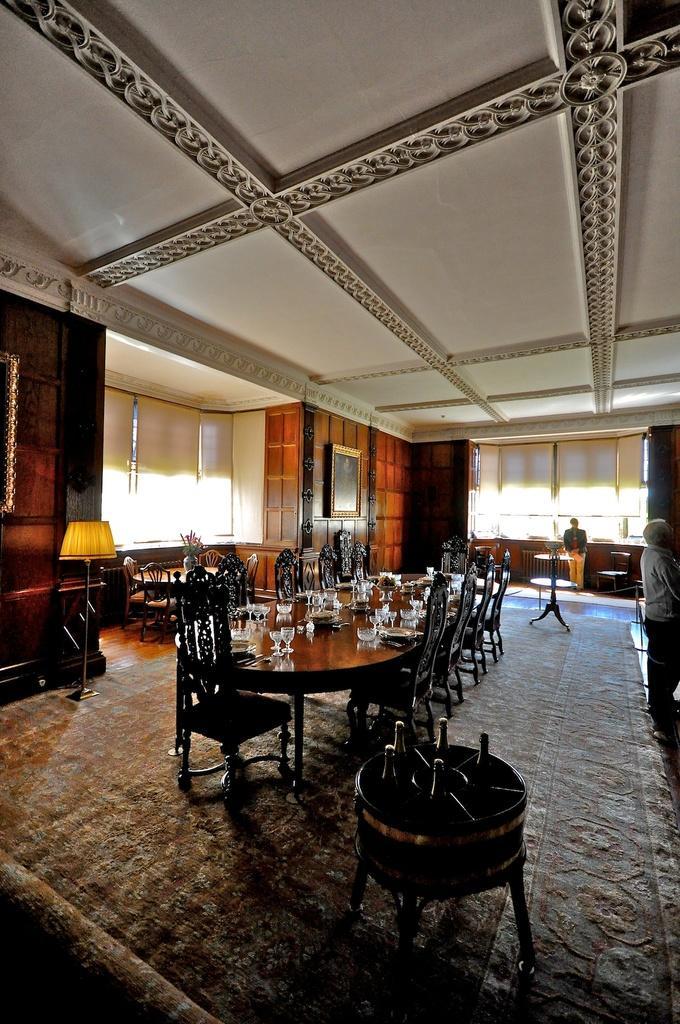Could you give a brief overview of what you see in this image? In this image there is a table with plates, glasses and some other objects, around the table there are chairs and there are a few more tables and chairs, there are a few people standing. In the background there are a few frames hanging on the wall and there are windows. 